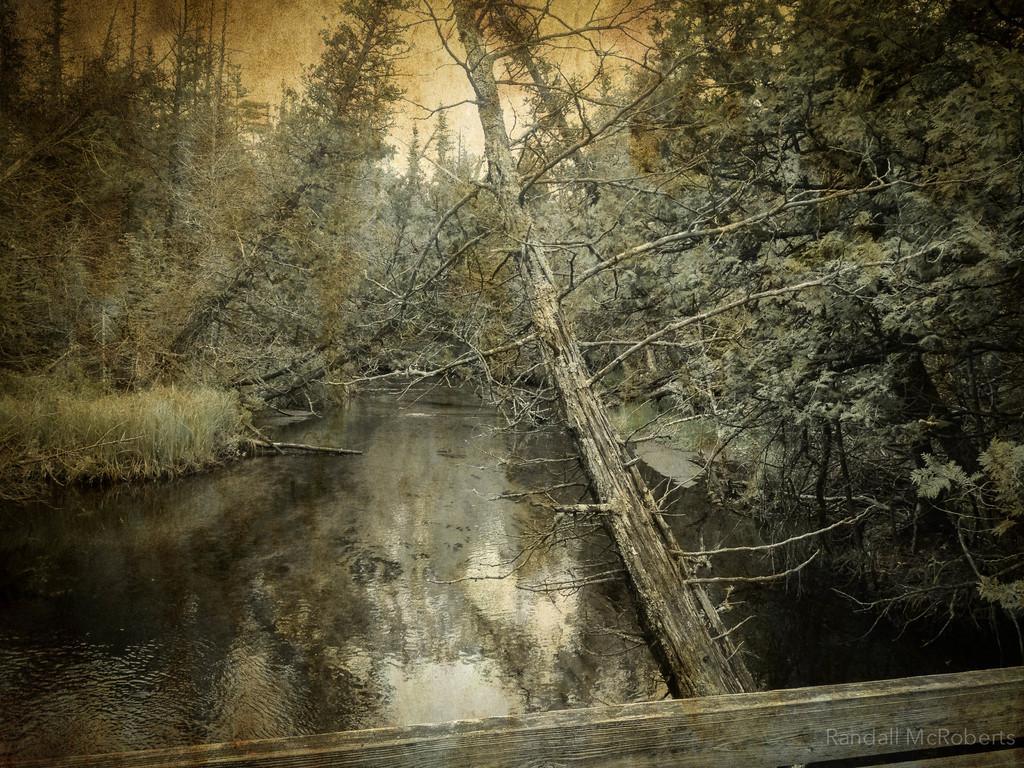In one or two sentences, can you explain what this image depicts? In this picture I can see trees and water and looks like a wooden bridge at the bottom of the picture and I can see text at the bottom right corner and I can see sky. 